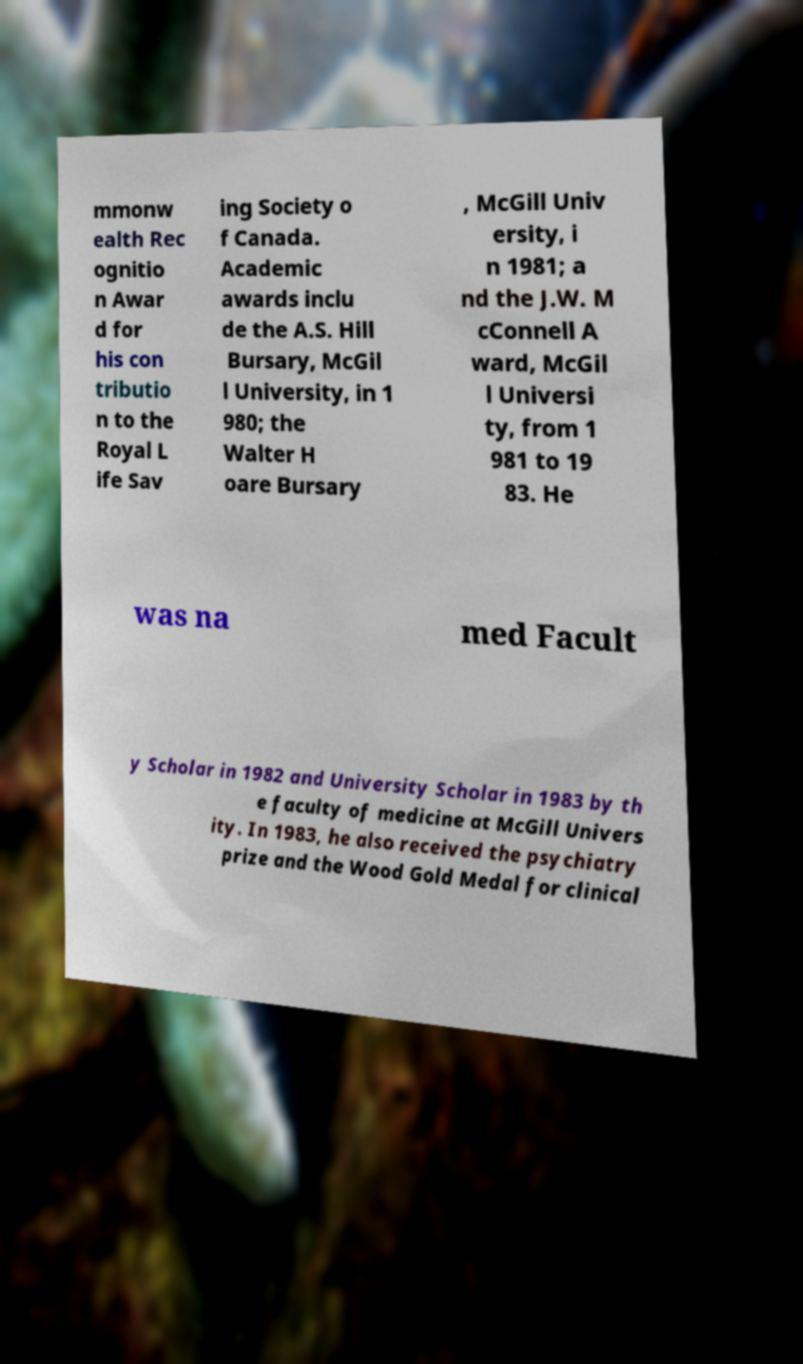Could you extract and type out the text from this image? mmonw ealth Rec ognitio n Awar d for his con tributio n to the Royal L ife Sav ing Society o f Canada. Academic awards inclu de the A.S. Hill Bursary, McGil l University, in 1 980; the Walter H oare Bursary , McGill Univ ersity, i n 1981; a nd the J.W. M cConnell A ward, McGil l Universi ty, from 1 981 to 19 83. He was na med Facult y Scholar in 1982 and University Scholar in 1983 by th e faculty of medicine at McGill Univers ity. In 1983, he also received the psychiatry prize and the Wood Gold Medal for clinical 